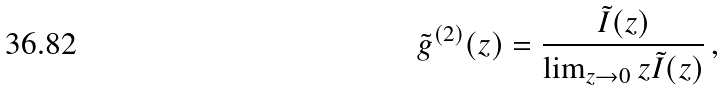Convert formula to latex. <formula><loc_0><loc_0><loc_500><loc_500>\tilde { g } ^ { ( 2 ) } ( z ) = \frac { \tilde { I } ( z ) } { \lim _ { z \rightarrow 0 } z \tilde { I } ( z ) } \, ,</formula> 